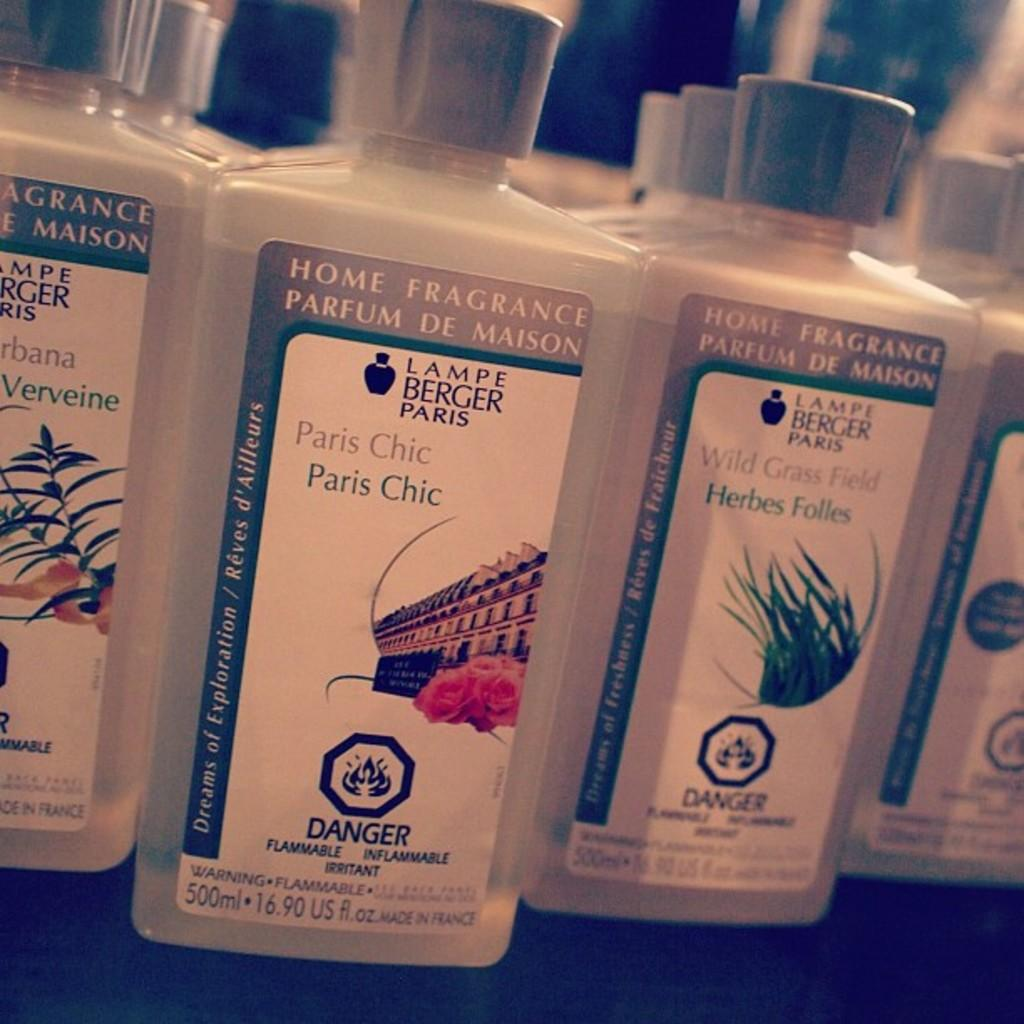<image>
Provide a brief description of the given image. Several bottles of "Parfum de Maison" placed in rows and sorted by brand. 